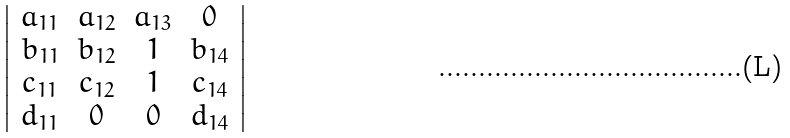<formula> <loc_0><loc_0><loc_500><loc_500>\left | \begin{array} { c c c c } a _ { 1 1 } & a _ { 1 2 } & a _ { 1 3 } & 0 \\ b _ { 1 1 } & b _ { 1 2 } & 1 & b _ { 1 4 } \\ c _ { 1 1 } & c _ { 1 2 } & 1 & c _ { 1 4 } \\ d _ { 1 1 } & 0 & 0 & d _ { 1 4 } \end{array} \right |</formula> 